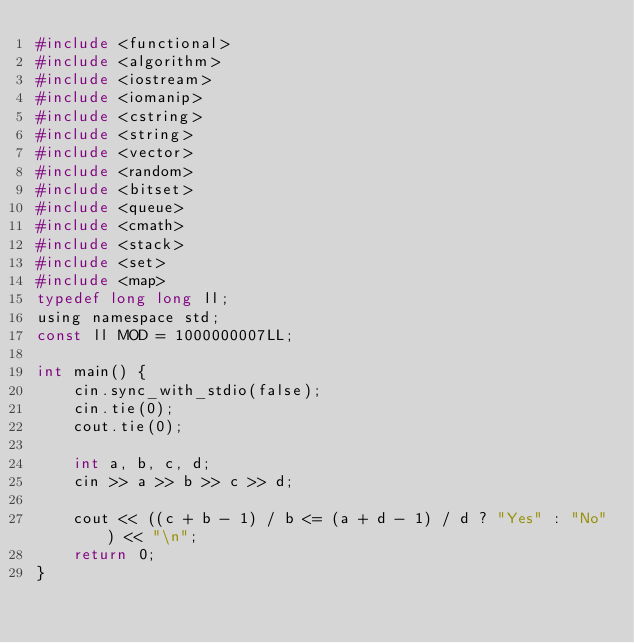Convert code to text. <code><loc_0><loc_0><loc_500><loc_500><_C_>#include <functional>
#include <algorithm>
#include <iostream>
#include <iomanip>
#include <cstring>
#include <string>
#include <vector>
#include <random>
#include <bitset>
#include <queue>
#include <cmath>
#include <stack>
#include <set>
#include <map>
typedef long long ll;
using namespace std;
const ll MOD = 1000000007LL;

int main() {
    cin.sync_with_stdio(false);
    cin.tie(0);
    cout.tie(0);

    int a, b, c, d;
    cin >> a >> b >> c >> d;

    cout << ((c + b - 1) / b <= (a + d - 1) / d ? "Yes" : "No") << "\n";
    return 0;
}</code> 